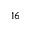Convert formula to latex. <formula><loc_0><loc_0><loc_500><loc_500>^ { 1 6 }</formula> 